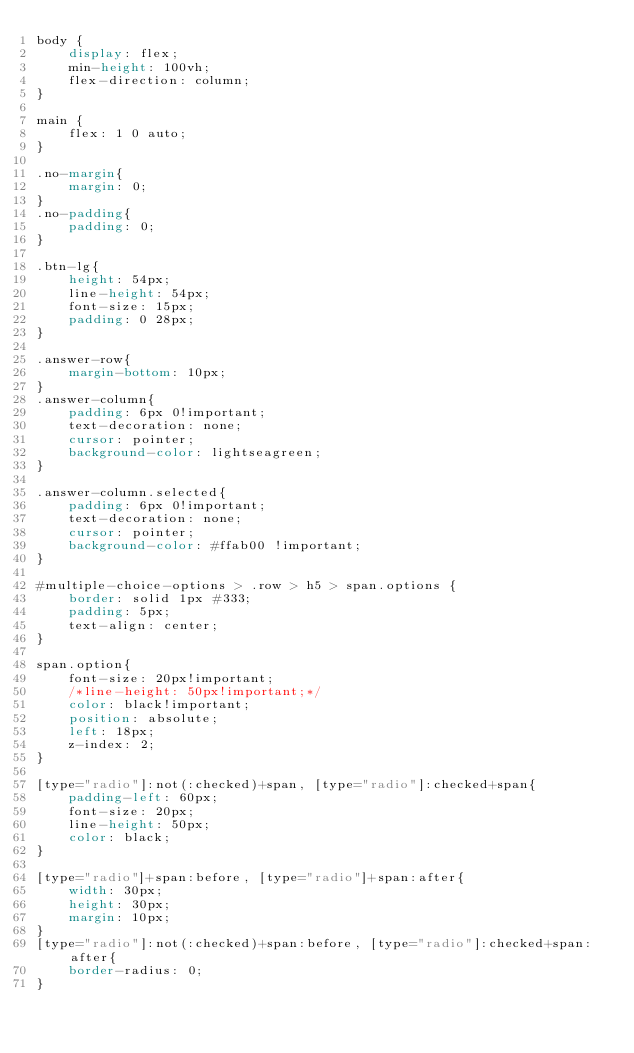Convert code to text. <code><loc_0><loc_0><loc_500><loc_500><_CSS_>body {
    display: flex;
    min-height: 100vh;
    flex-direction: column;
}

main {
    flex: 1 0 auto;
}

.no-margin{
    margin: 0;
}
.no-padding{
    padding: 0;
}

.btn-lg{
    height: 54px;
    line-height: 54px;
    font-size: 15px;
    padding: 0 28px;
}

.answer-row{
    margin-bottom: 10px;
}
.answer-column{
    padding: 6px 0!important;
    text-decoration: none;
    cursor: pointer;
    background-color: lightseagreen;
}

.answer-column.selected{
    padding: 6px 0!important;
    text-decoration: none;
    cursor: pointer;
    background-color: #ffab00 !important;
}

#multiple-choice-options > .row > h5 > span.options {
    border: solid 1px #333;
    padding: 5px;
    text-align: center;
}

span.option{
    font-size: 20px!important;
    /*line-height: 50px!important;*/
    color: black!important;
    position: absolute;
    left: 18px;
    z-index: 2;
}

[type="radio"]:not(:checked)+span, [type="radio"]:checked+span{
    padding-left: 60px;
    font-size: 20px;
    line-height: 50px;
    color: black;
}

[type="radio"]+span:before, [type="radio"]+span:after{
    width: 30px;
    height: 30px;
    margin: 10px;
}
[type="radio"]:not(:checked)+span:before, [type="radio"]:checked+span:after{
    border-radius: 0;
}
</code> 